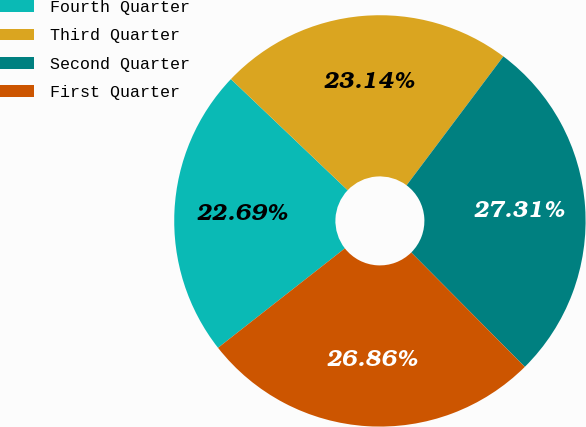Convert chart. <chart><loc_0><loc_0><loc_500><loc_500><pie_chart><fcel>Fourth Quarter<fcel>Third Quarter<fcel>Second Quarter<fcel>First Quarter<nl><fcel>22.69%<fcel>23.14%<fcel>27.31%<fcel>26.86%<nl></chart> 